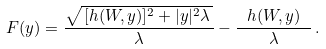<formula> <loc_0><loc_0><loc_500><loc_500>F ( y ) = \frac { \sqrt { \, [ h ( W , y ) ] ^ { 2 } + | y | ^ { 2 } \lambda \, } } { \lambda } - \frac { \ h ( W , y ) \ } { \lambda } \, .</formula> 